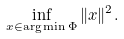<formula> <loc_0><loc_0><loc_500><loc_500>\inf _ { x \in \arg \min \Phi } \| x \| ^ { 2 } .</formula> 